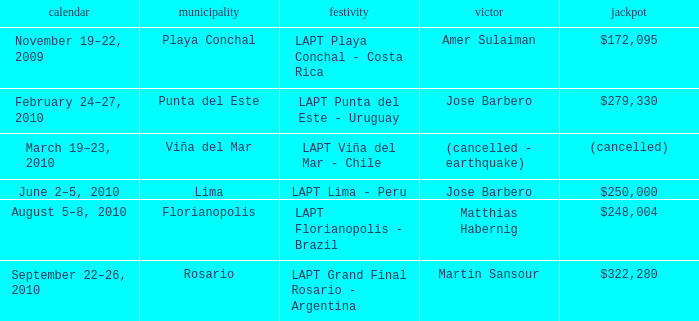What is the date of the event with a $322,280 prize? September 22–26, 2010. 